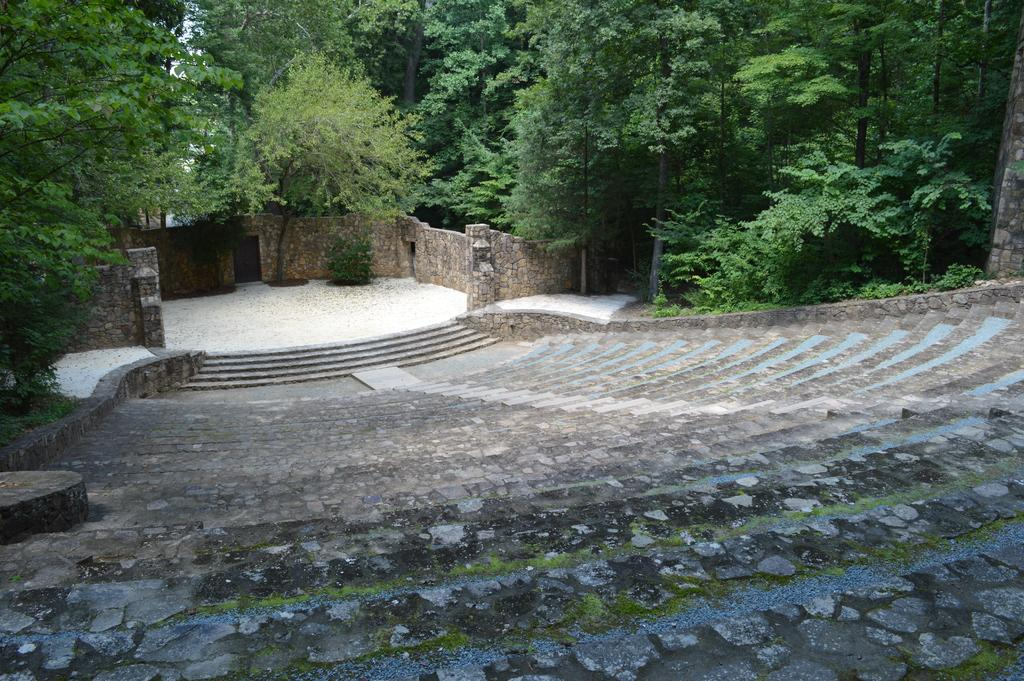What type of vegetation can be seen in the image? There are trees in the image. What architectural feature is present in the image? There are stairs in the image. How many sisters are smiling in the image? There are no people, let alone sisters, present in the image. The image only features trees and stairs. 